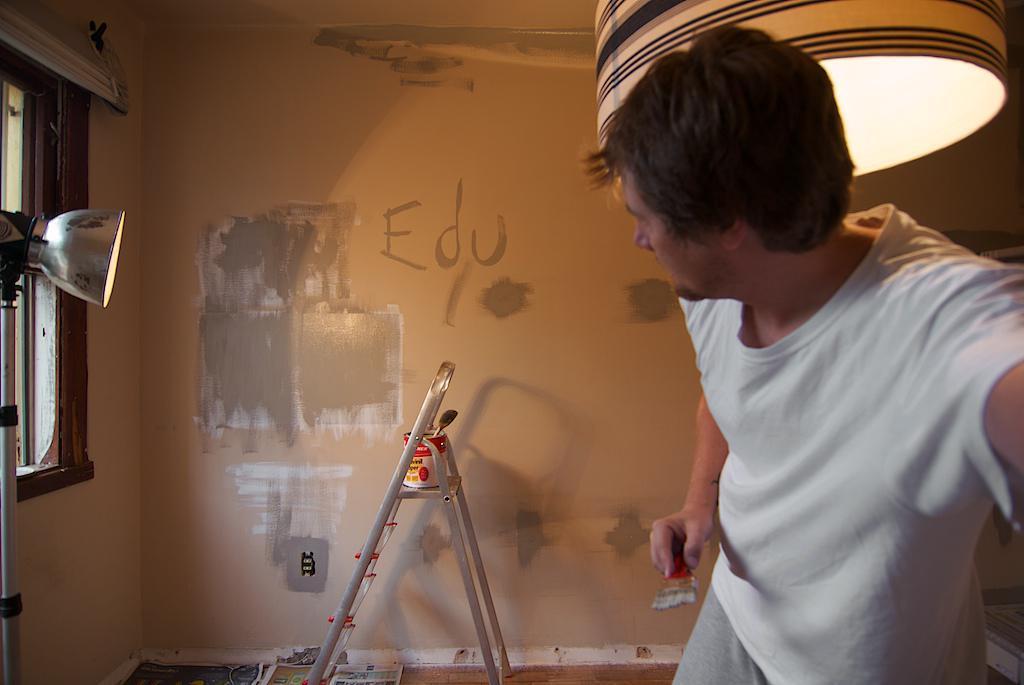Can you describe this image briefly? On the right there is a person holding a brush, behind him there is light. On the left there is a light and there is a window. In the center of the picture there are ladder, paint box, paper and wall. 